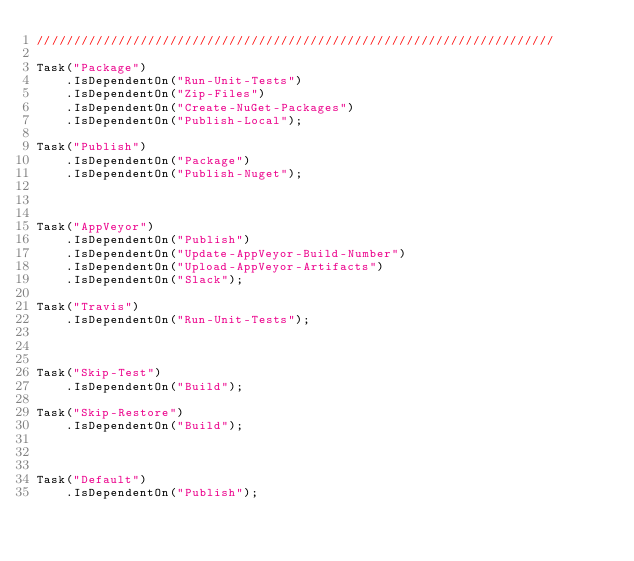Convert code to text. <code><loc_0><loc_0><loc_500><loc_500><_C#_>//////////////////////////////////////////////////////////////////////

Task("Package")
    .IsDependentOn("Run-Unit-Tests")
    .IsDependentOn("Zip-Files")
    .IsDependentOn("Create-NuGet-Packages")
    .IsDependentOn("Publish-Local");

Task("Publish")
	.IsDependentOn("Package")
    .IsDependentOn("Publish-Nuget");



Task("AppVeyor")
    .IsDependentOn("Publish")
    .IsDependentOn("Update-AppVeyor-Build-Number")
    .IsDependentOn("Upload-AppVeyor-Artifacts")
    .IsDependentOn("Slack");
	
Task("Travis")
    .IsDependentOn("Run-Unit-Tests");



Task("Skip-Test")
    .IsDependentOn("Build");

Task("Skip-Restore")
    .IsDependentOn("Build");



Task("Default")
    .IsDependentOn("Publish");
</code> 